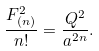<formula> <loc_0><loc_0><loc_500><loc_500>\frac { F _ { ( n ) } ^ { 2 } } { n ! } = \frac { Q ^ { 2 } } { a ^ { 2 n } } .</formula> 